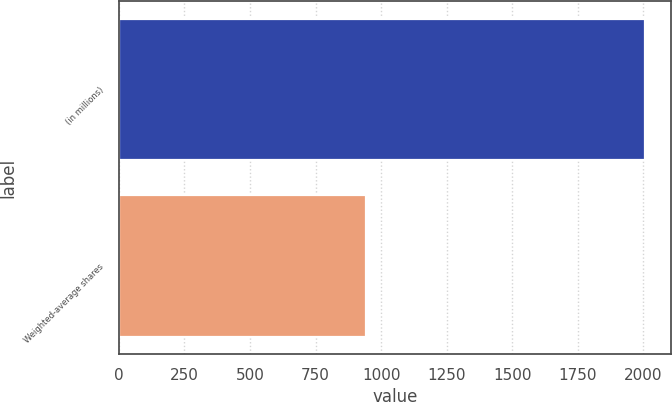Convert chart to OTSL. <chart><loc_0><loc_0><loc_500><loc_500><bar_chart><fcel>(in millions)<fcel>Weighted-average shares<nl><fcel>2005<fcel>943.72<nl></chart> 